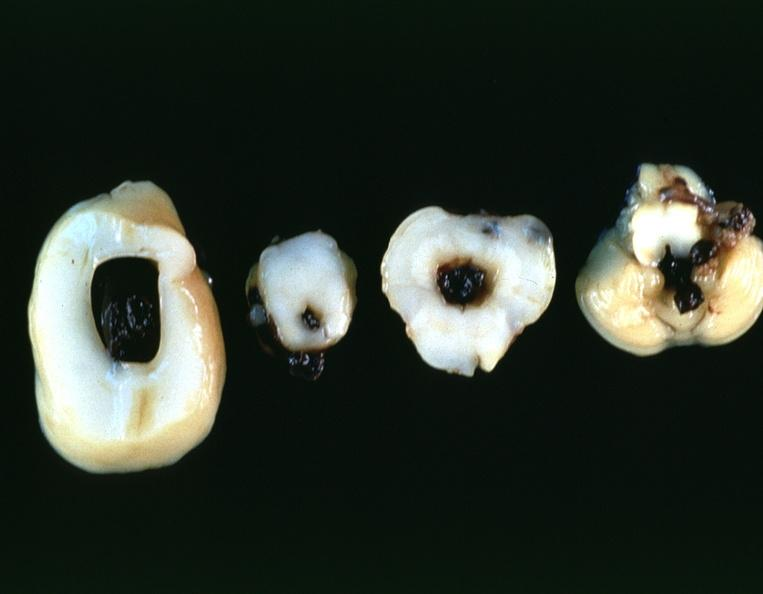does amebiasis show brain, intraventricular hemmorrhage in a prematue baby with hyaline membrane disease?
Answer the question using a single word or phrase. No 